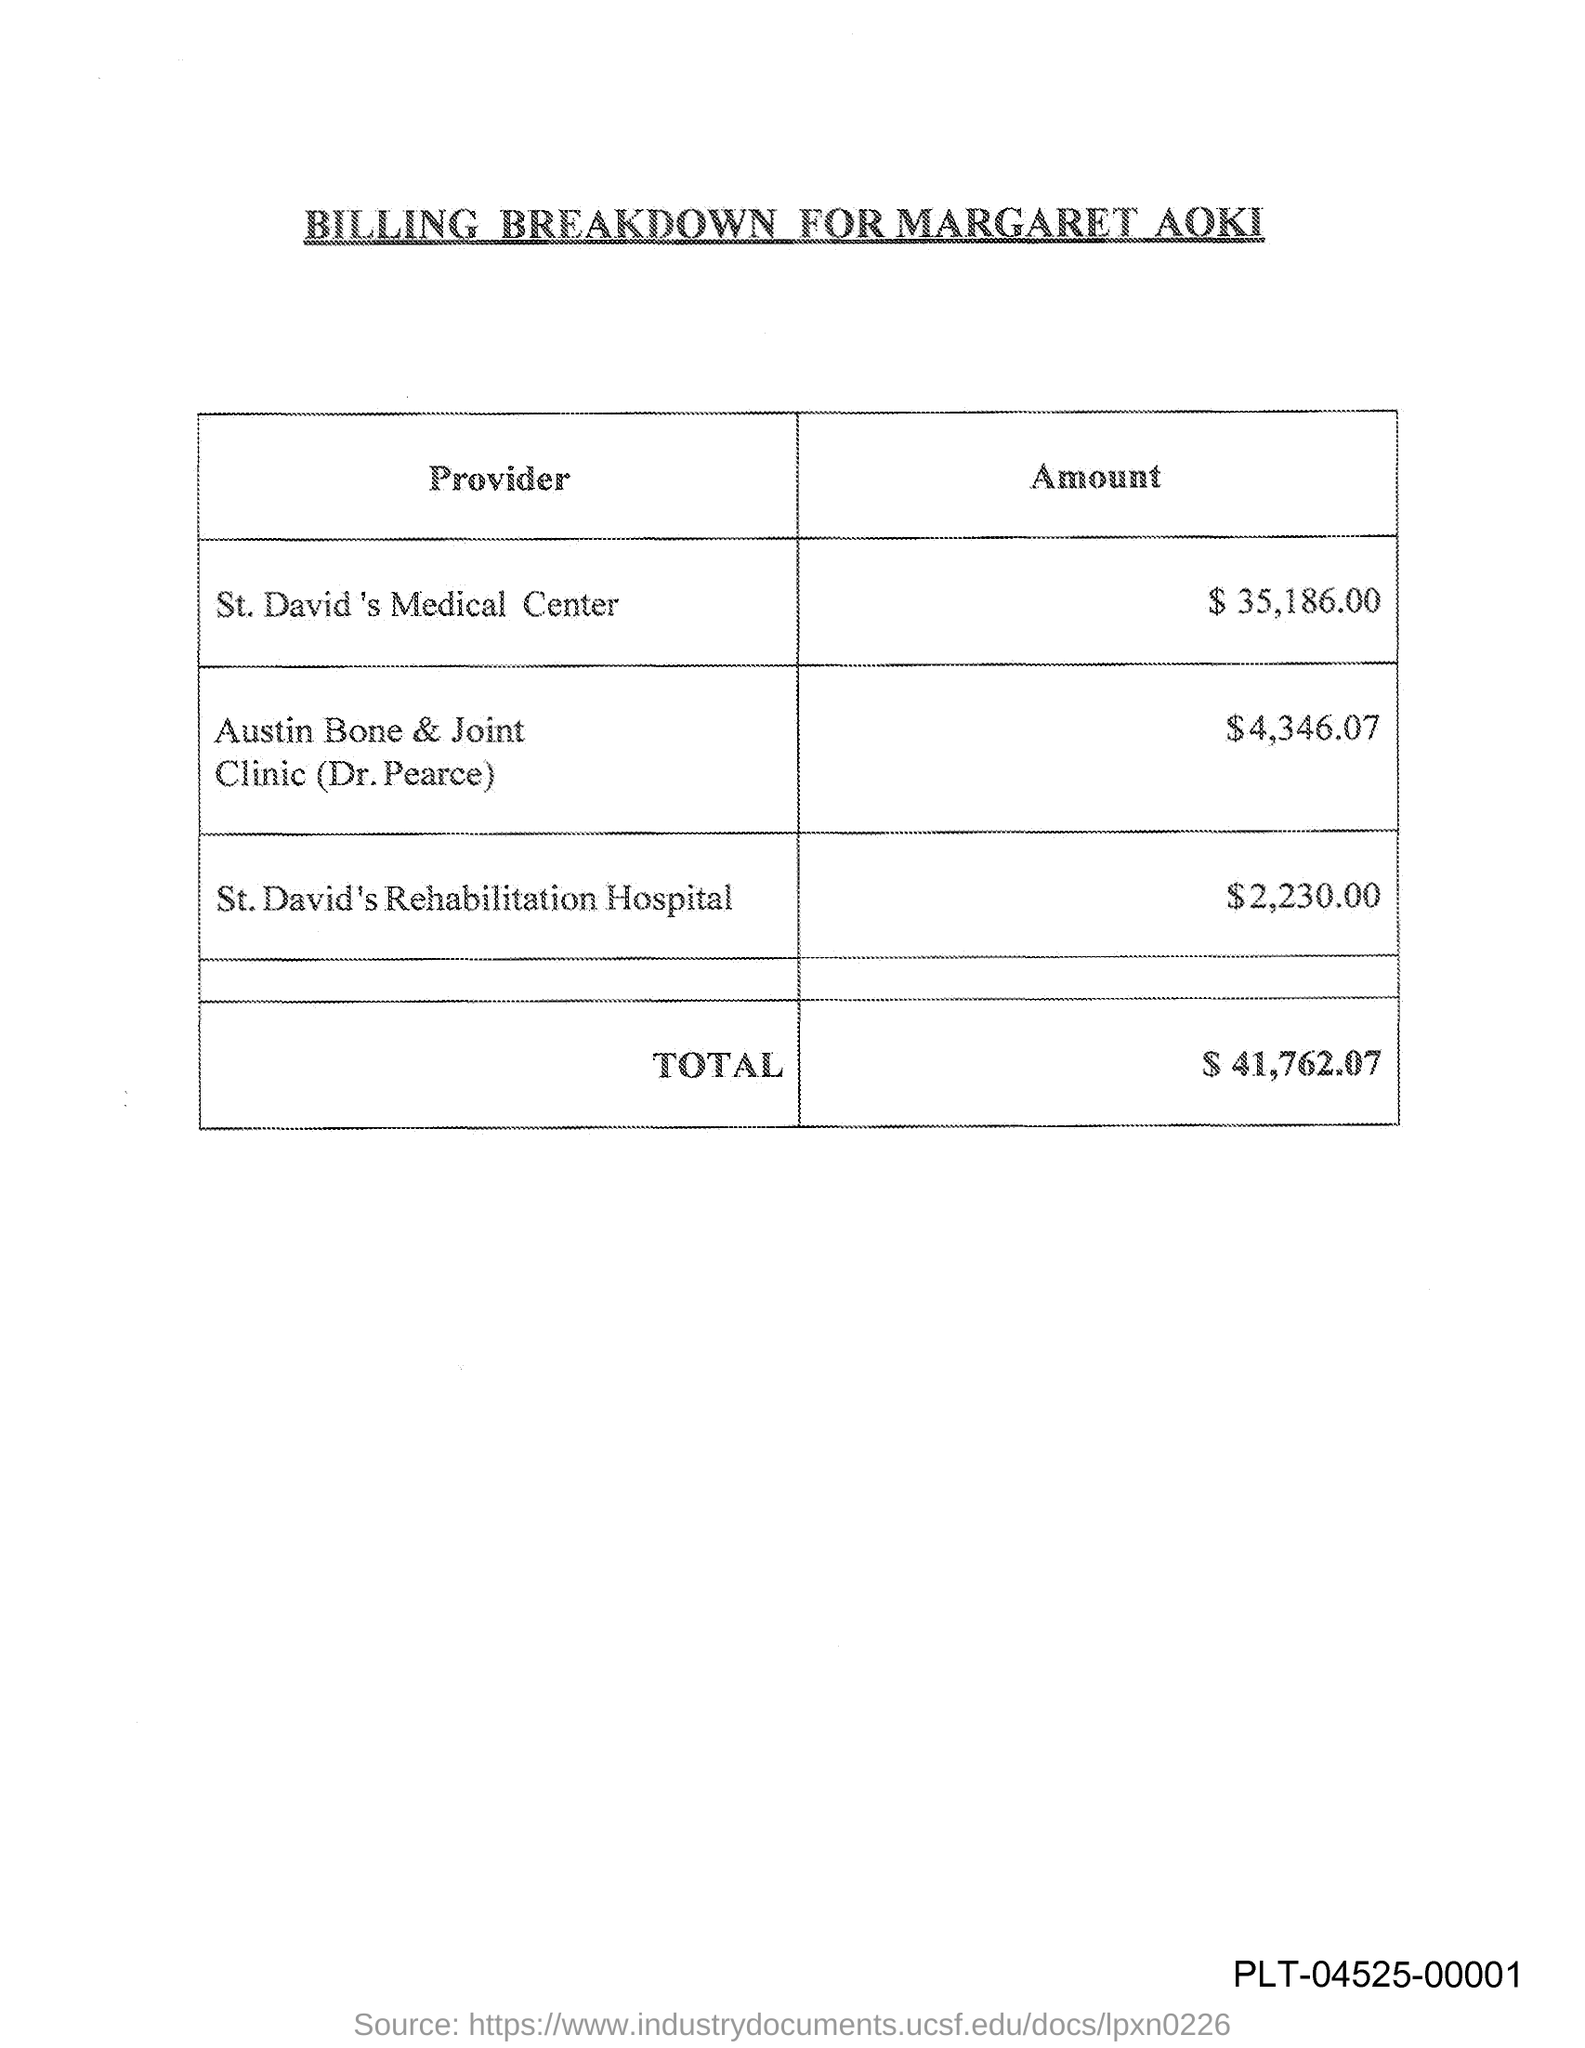Indicate a few pertinent items in this graphic. The total amount given in the document is $41,762.07. The amount mentioned is $2,230.00 for St. David's Rehabilitation Hospital. The amount mentioned for St. David's Medical Center is $35,186.00. This document is titled 'Billing Breakdown for Margaret Aoki.' 